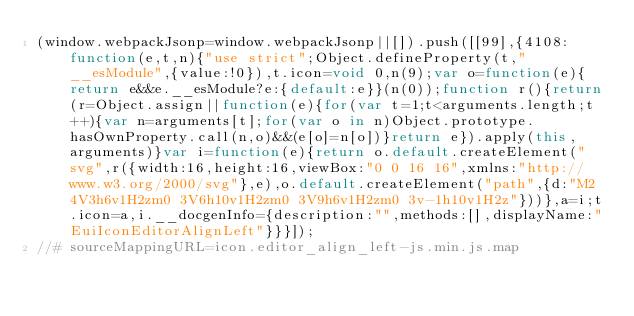Convert code to text. <code><loc_0><loc_0><loc_500><loc_500><_JavaScript_>(window.webpackJsonp=window.webpackJsonp||[]).push([[99],{4108:function(e,t,n){"use strict";Object.defineProperty(t,"__esModule",{value:!0}),t.icon=void 0,n(9);var o=function(e){return e&&e.__esModule?e:{default:e}}(n(0));function r(){return(r=Object.assign||function(e){for(var t=1;t<arguments.length;t++){var n=arguments[t];for(var o in n)Object.prototype.hasOwnProperty.call(n,o)&&(e[o]=n[o])}return e}).apply(this,arguments)}var i=function(e){return o.default.createElement("svg",r({width:16,height:16,viewBox:"0 0 16 16",xmlns:"http://www.w3.org/2000/svg"},e),o.default.createElement("path",{d:"M2 4V3h6v1H2zm0 3V6h10v1H2zm0 3V9h6v1H2zm0 3v-1h10v1H2z"}))},a=i;t.icon=a,i.__docgenInfo={description:"",methods:[],displayName:"EuiIconEditorAlignLeft"}}}]);
//# sourceMappingURL=icon.editor_align_left-js.min.js.map</code> 